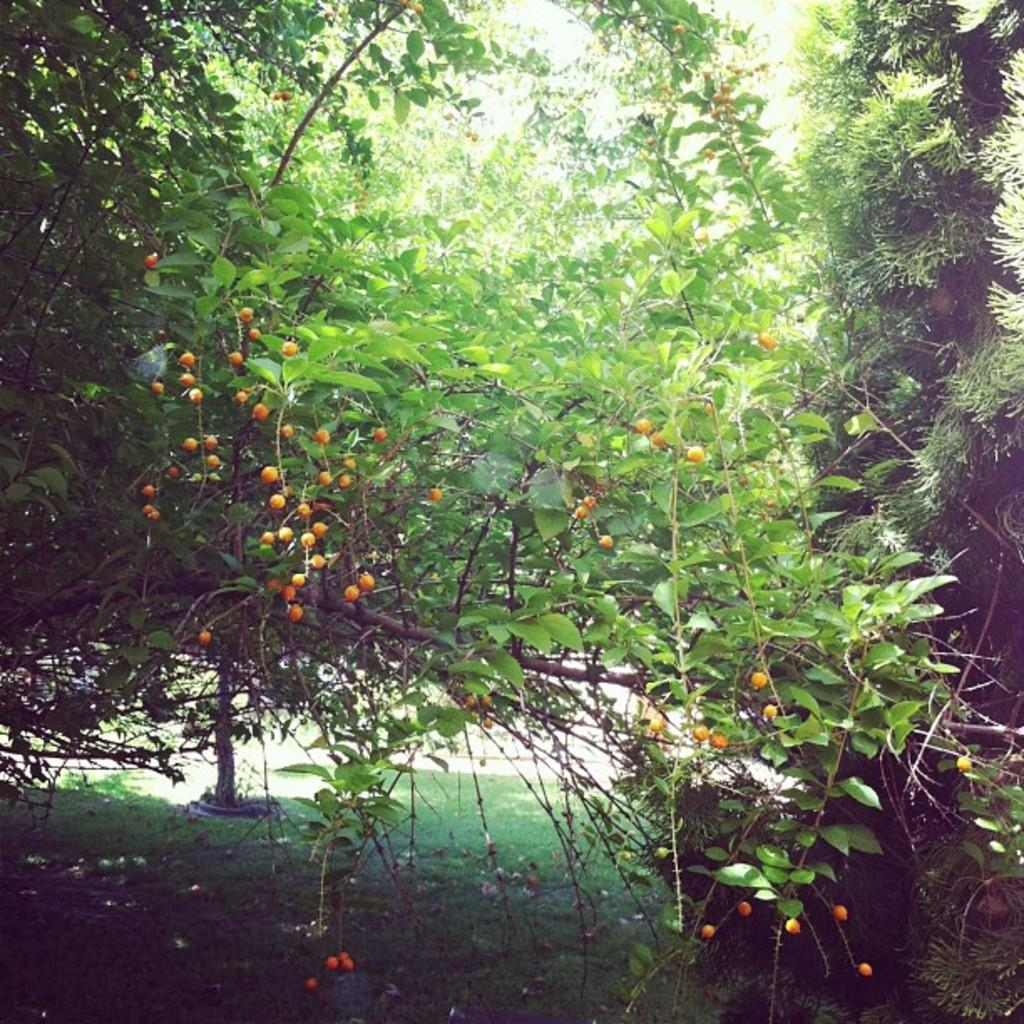What type of vegetation can be seen in the image? There are trees in the image. What is growing on the trees? Fruits are visible on the trees. What is present at the bottom of the image? There is grass at the bottom of the image. What type of chess piece can be seen on the grass in the image? There is no chess piece present in the image; it features trees with fruits and grass. What is the reaction of the farmer to the fruits on the trees in the image? There is no farmer present in the image, so it is not possible to determine their reaction to the fruits on the trees. 